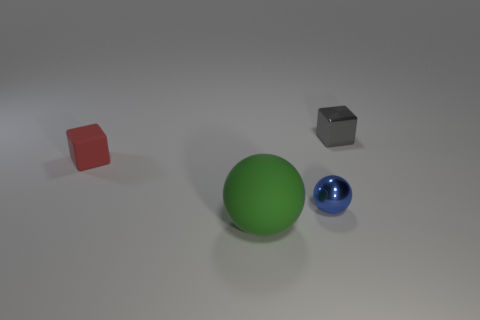Is the blue thing made of the same material as the tiny red thing?
Make the answer very short. No. There is a tiny metal thing that is in front of the tiny red object; what number of small spheres are in front of it?
Give a very brief answer. 0. Does the red matte thing have the same size as the green matte thing?
Ensure brevity in your answer.  No. How many other tiny balls have the same material as the green ball?
Provide a short and direct response. 0. What size is the gray thing that is the same shape as the red thing?
Your answer should be very brief. Small. Is the shape of the tiny shiny thing that is on the left side of the tiny gray shiny thing the same as  the small matte thing?
Your answer should be compact. No. There is a metallic thing that is behind the shiny thing in front of the shiny block; what shape is it?
Keep it short and to the point. Cube. Is there anything else that is the same shape as the tiny blue thing?
Give a very brief answer. Yes. There is another small object that is the same shape as the green matte object; what is its color?
Your answer should be very brief. Blue. Do the small sphere and the rubber object that is in front of the small red matte block have the same color?
Provide a short and direct response. No. 